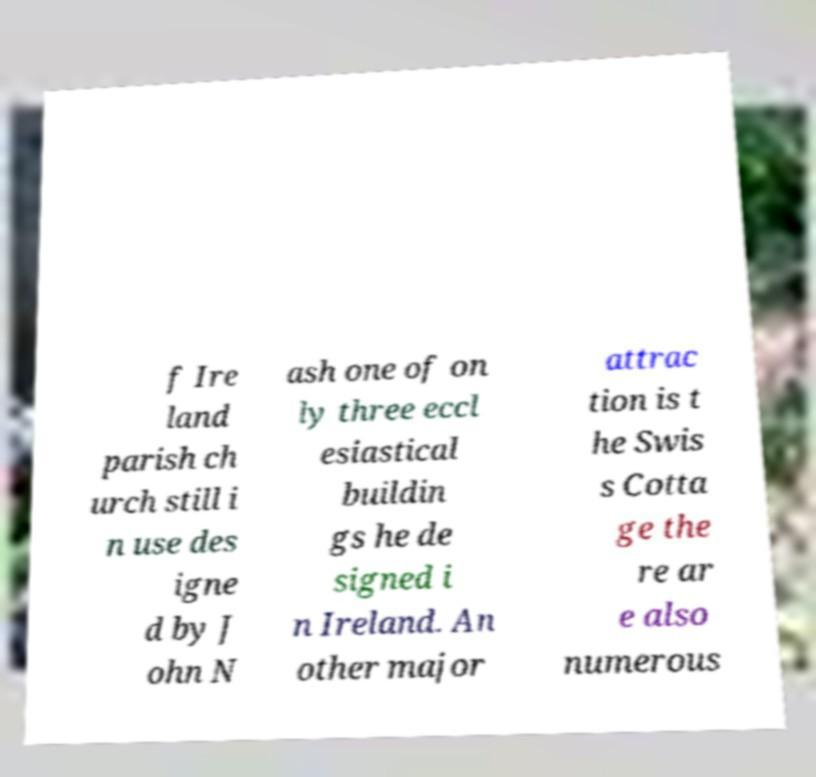Can you accurately transcribe the text from the provided image for me? f Ire land parish ch urch still i n use des igne d by J ohn N ash one of on ly three eccl esiastical buildin gs he de signed i n Ireland. An other major attrac tion is t he Swis s Cotta ge the re ar e also numerous 